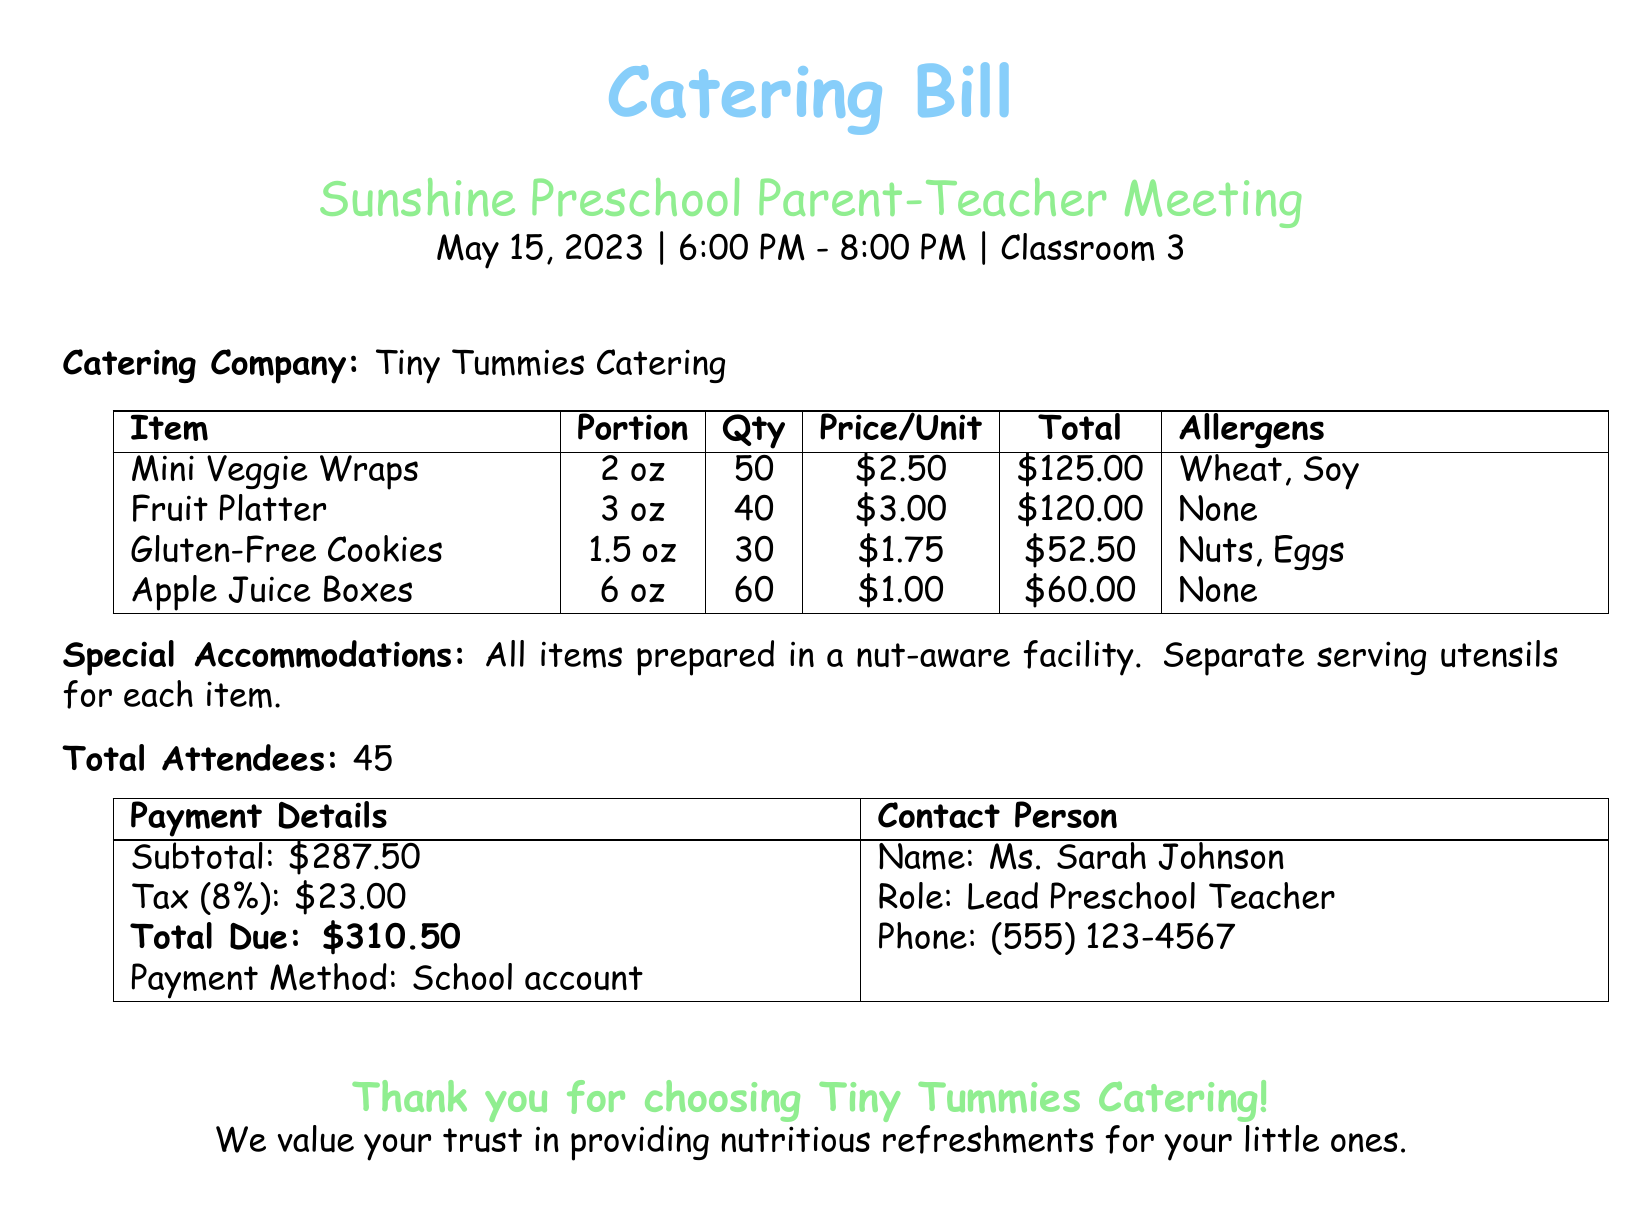what is the name of the catering company? The name of the catering company is specified in the document, which is Tiny Tummies Catering.
Answer: Tiny Tummies Catering what is the total number of attendees? The total number of attendees is mentioned in the document as 45.
Answer: 45 what is the portion size of the Fruit Platter? The portion size for the Fruit Platter is included in the document and is stated as 3 oz.
Answer: 3 oz how much do the Gluten-Free Cookies cost per unit? The cost per unit for Gluten-Free Cookies is listed in the document as $1.75.
Answer: $1.75 what allergens are present in the Mini Veggie Wraps? The allergens for the Mini Veggie Wraps are explicitly stated in the document as Wheat and Soy.
Answer: Wheat, Soy what is the total amount due? The total amount due is clearly stated in the payment details section as $310.50.
Answer: $310.50 how many Apple Juice Boxes will be served? The quantity of Apple Juice Boxes provided in the document is 60.
Answer: 60 what role does Ms. Sarah Johnson have? The document indicates that Ms. Sarah Johnson's role is Lead Preschool Teacher.
Answer: Lead Preschool Teacher why are separate serving utensils used? The document mentions that separate serving utensils are used for safety, particularly since all items are prepared in a nut-aware facility.
Answer: Safety 